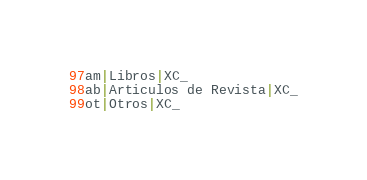Convert code to text. <code><loc_0><loc_0><loc_500><loc_500><_SQL_>am|Libros|XC_
ab|Articulos de Revista|XC_
ot|Otros|XC_
</code> 